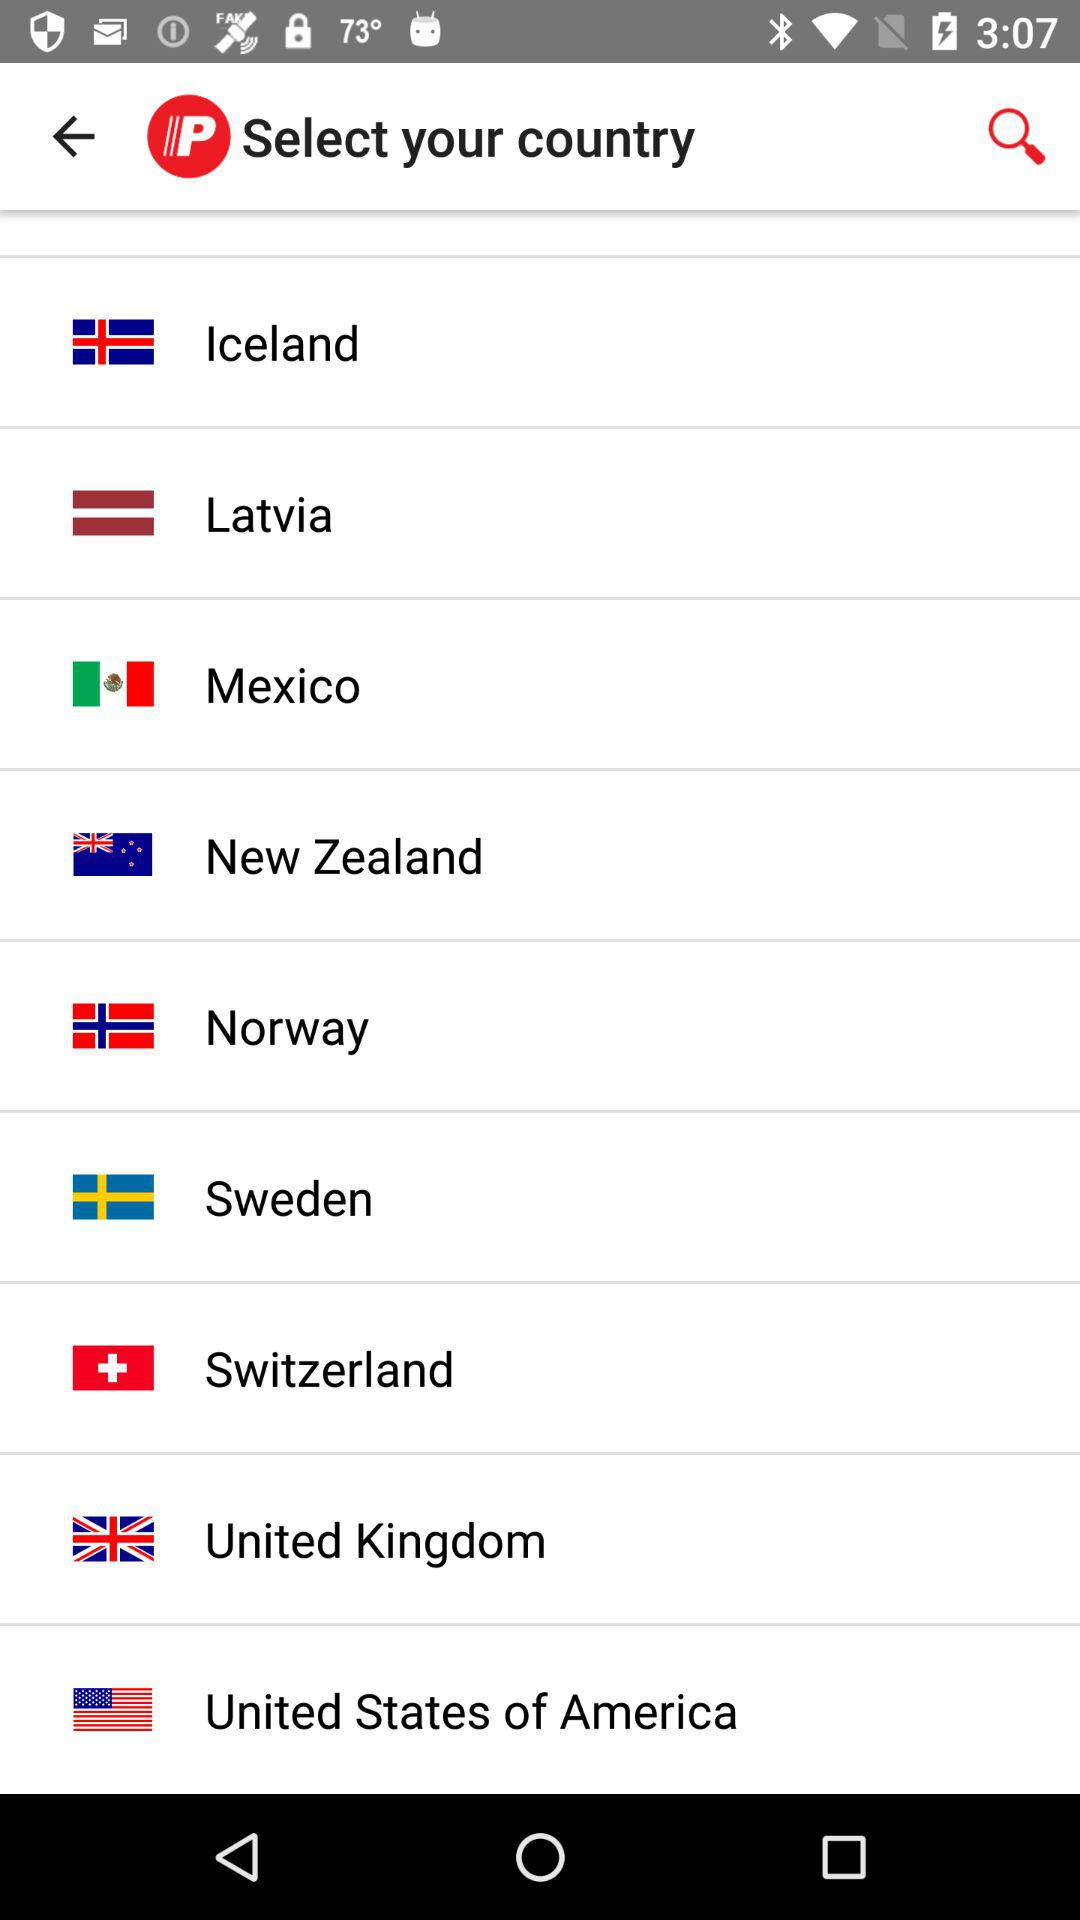What are the available options? The available options are "Iceland", "Latvia", "Mexico", "New Zealand", "Norway", "Sweden", "Switzerland", "United Kingdom" and "United States of America". 